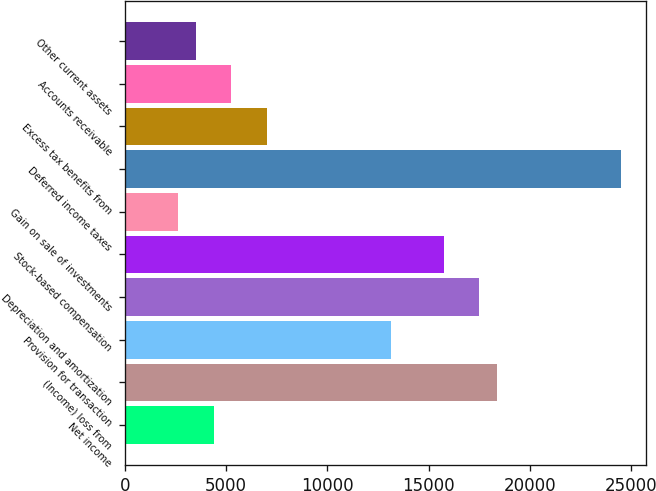Convert chart. <chart><loc_0><loc_0><loc_500><loc_500><bar_chart><fcel>Net income<fcel>(Income) loss from<fcel>Provision for transaction<fcel>Depreciation and amortization<fcel>Stock-based compensation<fcel>Gain on sale of investments<fcel>Deferred income taxes<fcel>Excess tax benefits from<fcel>Accounts receivable<fcel>Other current assets<nl><fcel>4377.5<fcel>18375.9<fcel>13126.5<fcel>17501<fcel>15751.2<fcel>2627.7<fcel>24500.2<fcel>7002.2<fcel>5252.4<fcel>3502.6<nl></chart> 